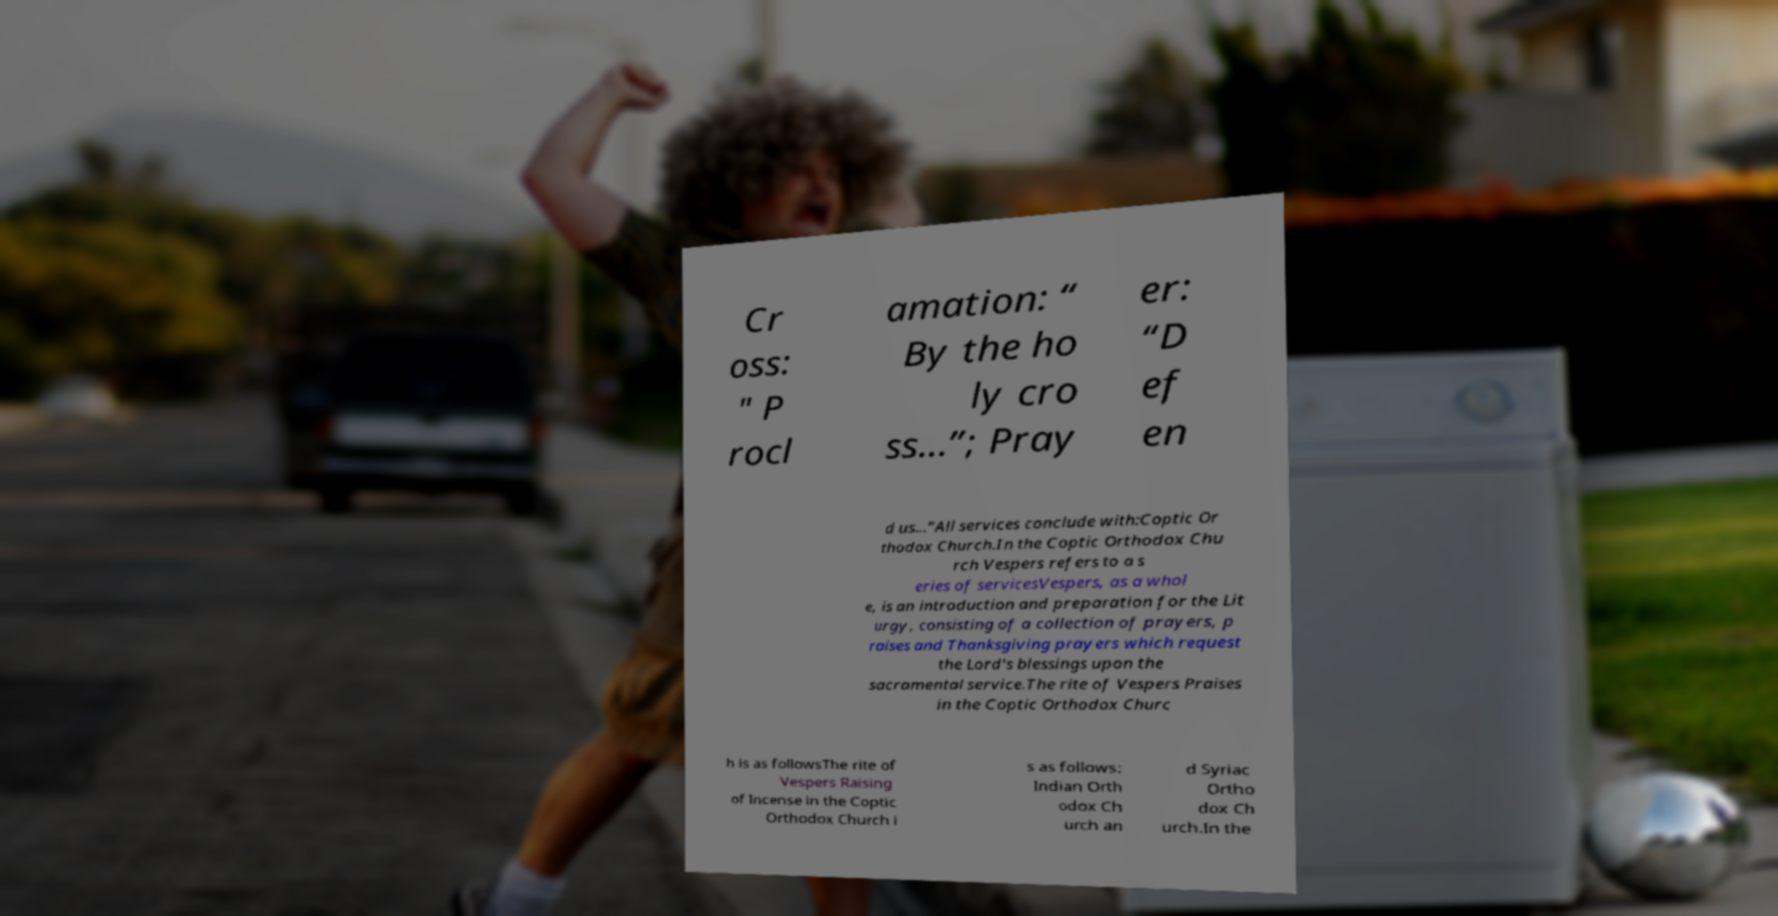I need the written content from this picture converted into text. Can you do that? Cr oss: " P rocl amation: “ By the ho ly cro ss...”; Pray er: “D ef en d us...”All services conclude with:Coptic Or thodox Church.In the Coptic Orthodox Chu rch Vespers refers to a s eries of servicesVespers, as a whol e, is an introduction and preparation for the Lit urgy, consisting of a collection of prayers, p raises and Thanksgiving prayers which request the Lord's blessings upon the sacramental service.The rite of Vespers Praises in the Coptic Orthodox Churc h is as followsThe rite of Vespers Raising of Incense in the Coptic Orthodox Church i s as follows: Indian Orth odox Ch urch an d Syriac Ortho dox Ch urch.In the 